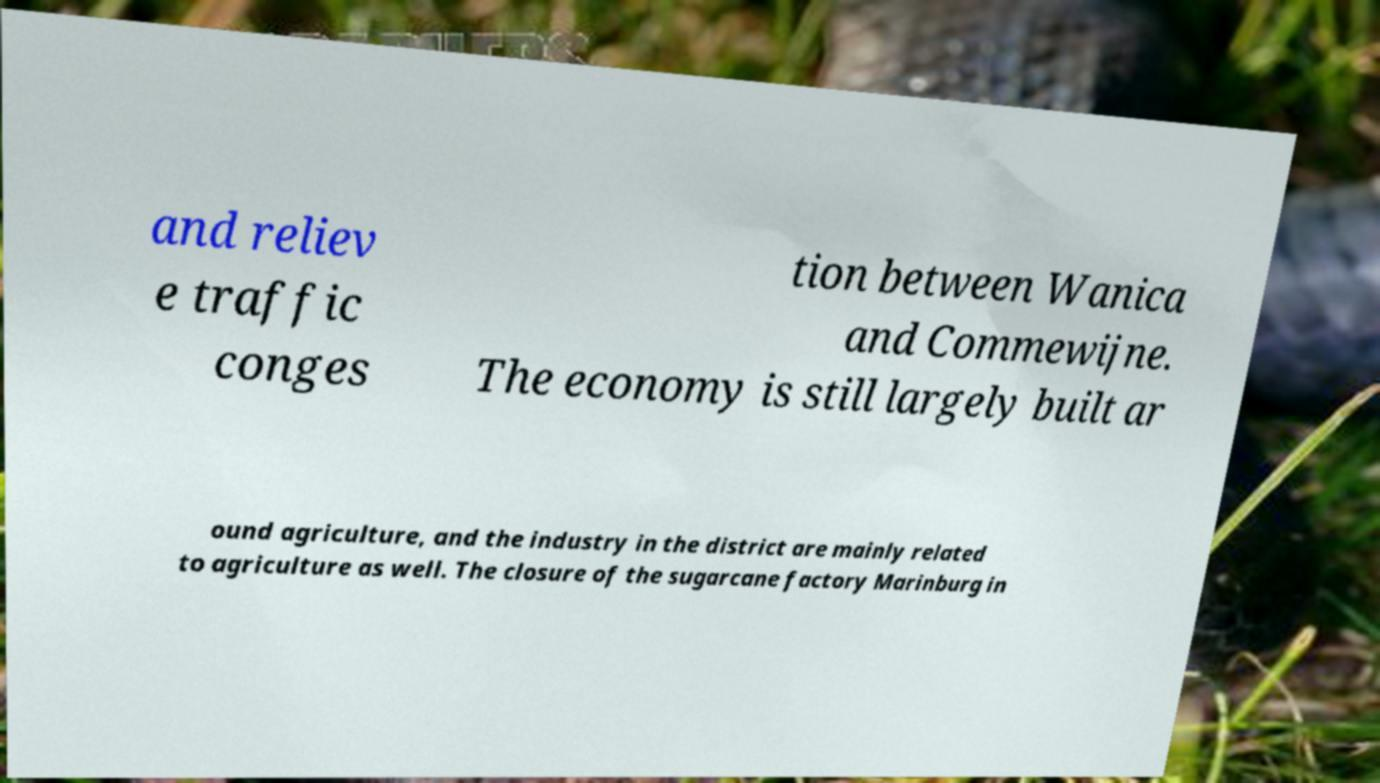Could you extract and type out the text from this image? and reliev e traffic conges tion between Wanica and Commewijne. The economy is still largely built ar ound agriculture, and the industry in the district are mainly related to agriculture as well. The closure of the sugarcane factory Marinburg in 